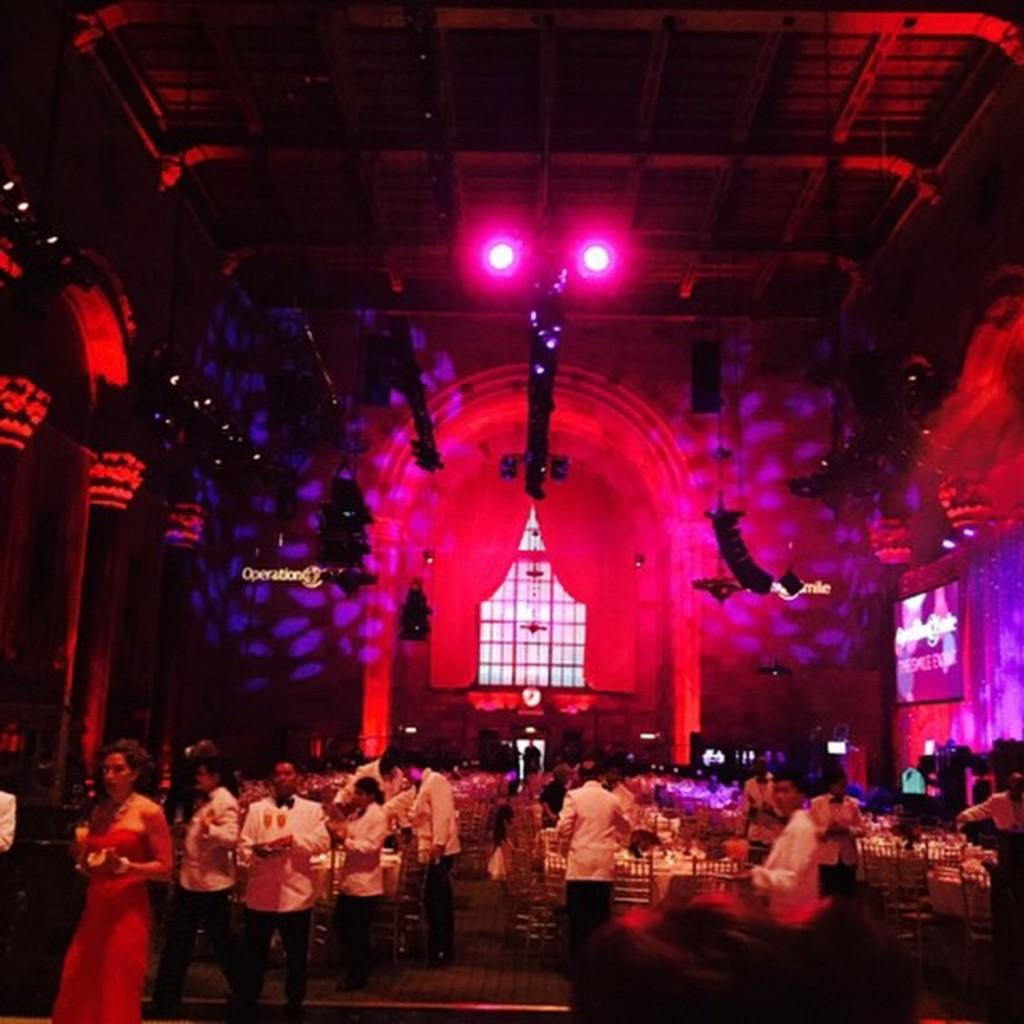How many people are in the image? There is a group of people standing in the image, but the exact number cannot be determined from the provided facts. What type of furniture is present in the image? There are tables and chairs in the image. What items might be used for eating or drinking in the image? There are glasses and plates in the image. What type of lighting is present in the image? There are lights in the image. What type of display device is present in the image? There is a screen in the image. What type of architectural feature is present in the image? There are pillars in the image. What type of spade is being used by one of the people in the image? There is no spade present in the image. Why are the people in the image crying? There is no indication in the image that the people are crying. 